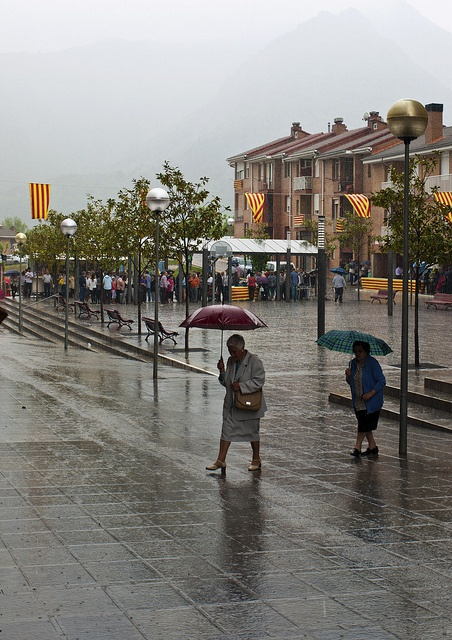Describe the objects in this image and their specific colors. I can see people in white, black, gray, darkgreen, and maroon tones, people in white, black, and gray tones, people in white, black, gray, and darkgray tones, umbrella in white, black, maroon, brown, and darkgray tones, and umbrella in white, black, teal, navy, and darkgreen tones in this image. 